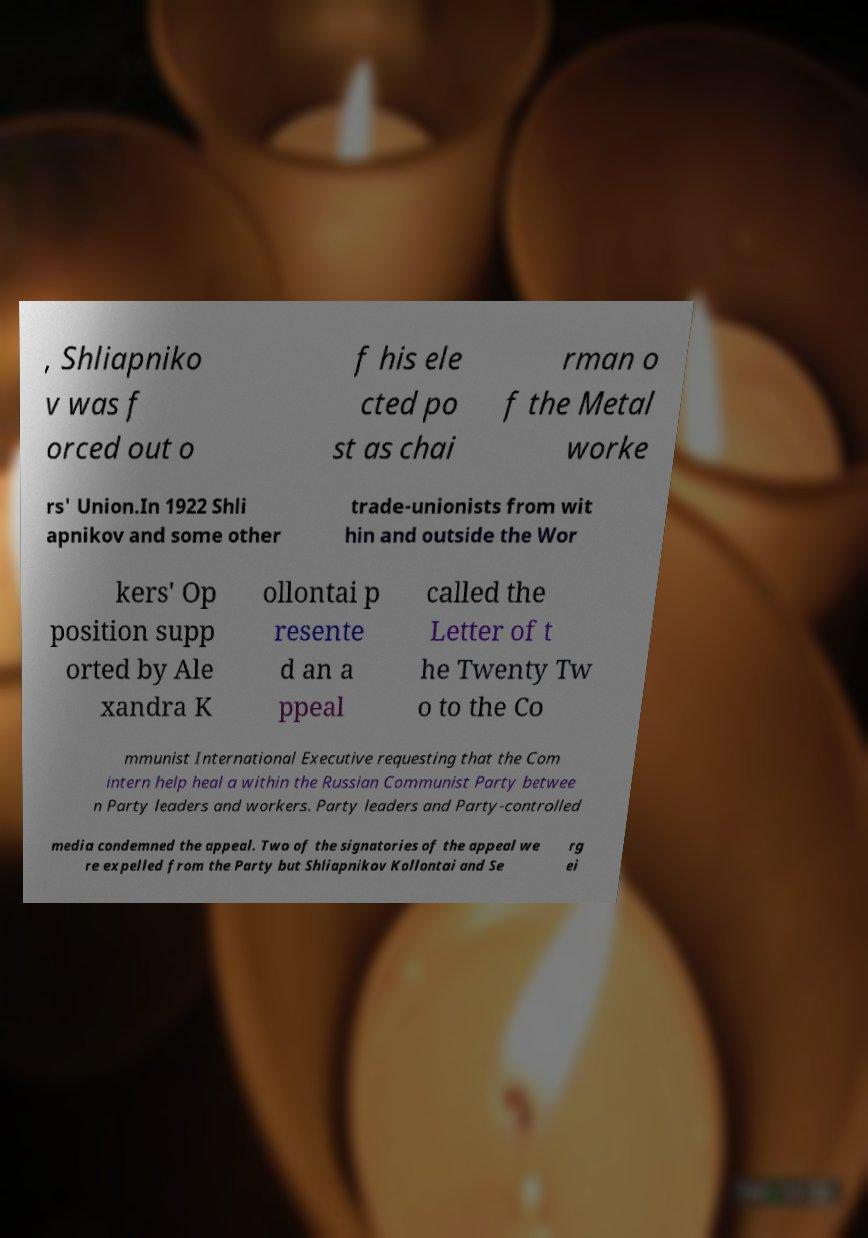Could you extract and type out the text from this image? , Shliapniko v was f orced out o f his ele cted po st as chai rman o f the Metal worke rs' Union.In 1922 Shli apnikov and some other trade-unionists from wit hin and outside the Wor kers' Op position supp orted by Ale xandra K ollontai p resente d an a ppeal called the Letter of t he Twenty Tw o to the Co mmunist International Executive requesting that the Com intern help heal a within the Russian Communist Party betwee n Party leaders and workers. Party leaders and Party-controlled media condemned the appeal. Two of the signatories of the appeal we re expelled from the Party but Shliapnikov Kollontai and Se rg ei 